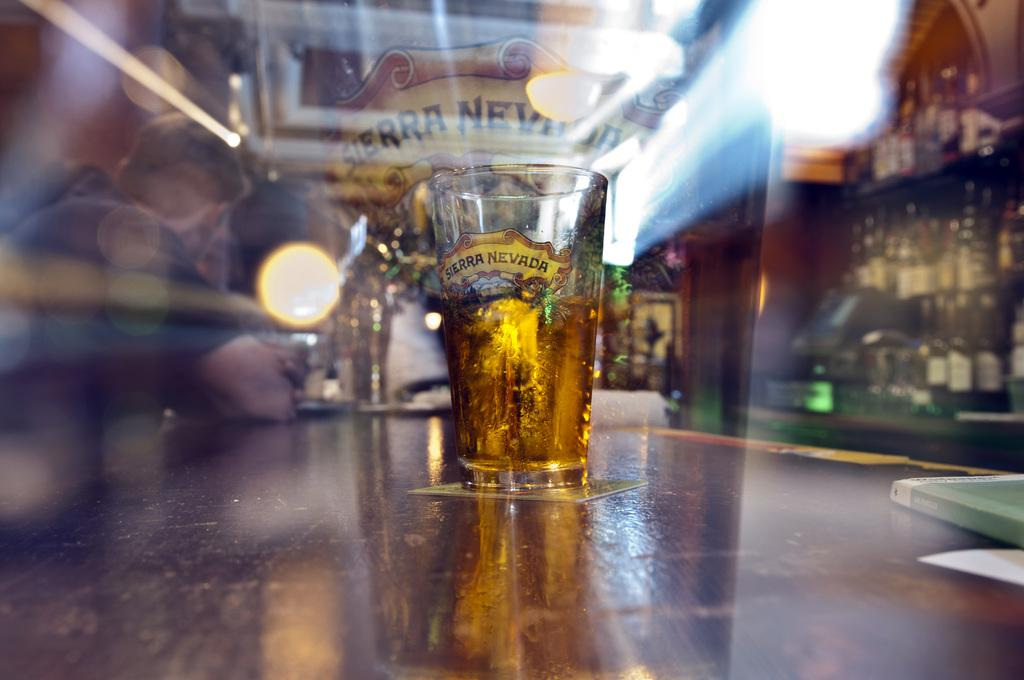Provide a one-sentence caption for the provided image. A glass on a table in a bar of Sierra Nevada. 